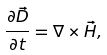<formula> <loc_0><loc_0><loc_500><loc_500>\frac { \partial \vec { D } } { \partial t } = \nabla \times \vec { H } ,</formula> 